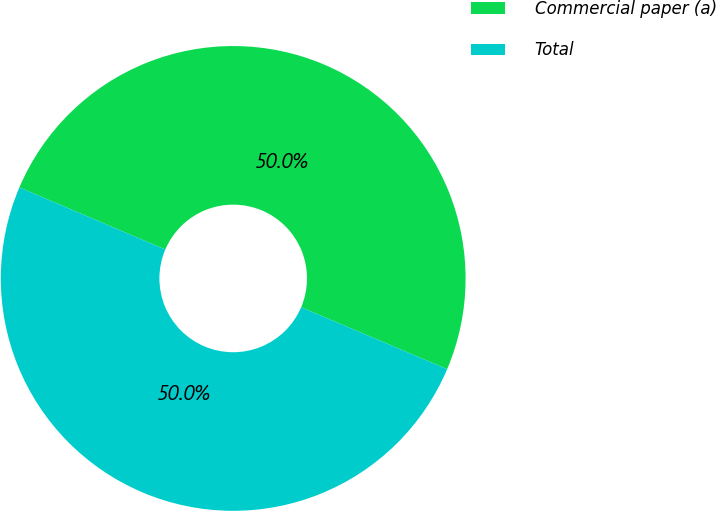Convert chart. <chart><loc_0><loc_0><loc_500><loc_500><pie_chart><fcel>Commercial paper (a)<fcel>Total<nl><fcel>49.98%<fcel>50.02%<nl></chart> 